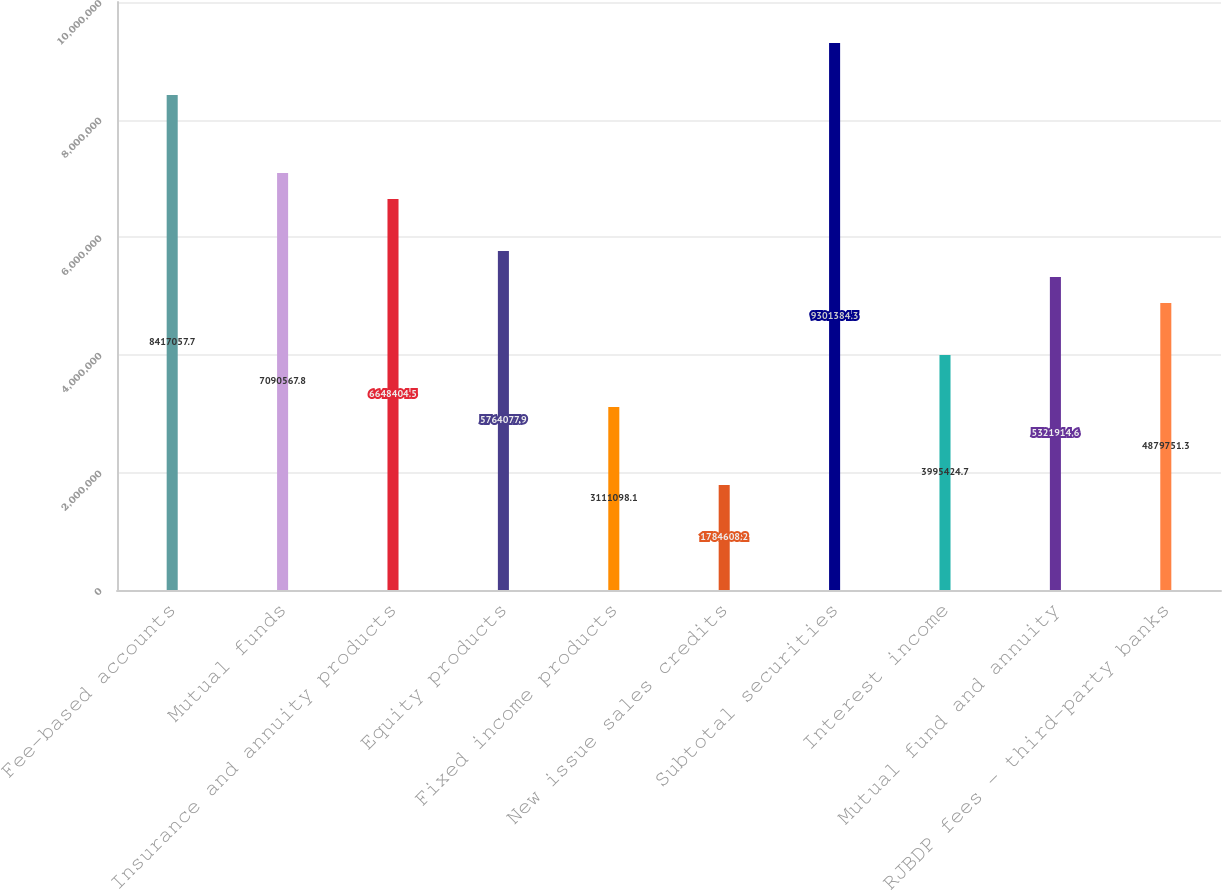Convert chart to OTSL. <chart><loc_0><loc_0><loc_500><loc_500><bar_chart><fcel>Fee-based accounts<fcel>Mutual funds<fcel>Insurance and annuity products<fcel>Equity products<fcel>Fixed income products<fcel>New issue sales credits<fcel>Subtotal securities<fcel>Interest income<fcel>Mutual fund and annuity<fcel>RJBDP fees - third-party banks<nl><fcel>8.41706e+06<fcel>7.09057e+06<fcel>6.6484e+06<fcel>5.76408e+06<fcel>3.1111e+06<fcel>1.78461e+06<fcel>9.30138e+06<fcel>3.99542e+06<fcel>5.32191e+06<fcel>4.87975e+06<nl></chart> 